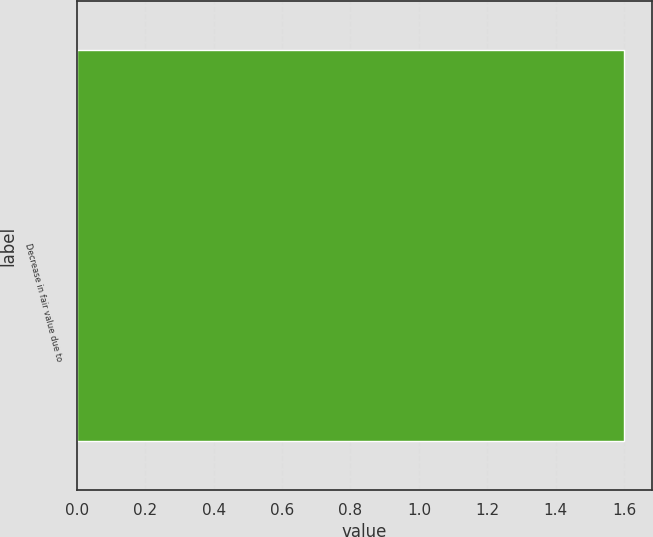Convert chart. <chart><loc_0><loc_0><loc_500><loc_500><bar_chart><fcel>Decrease in fair value due to<nl><fcel>1.6<nl></chart> 